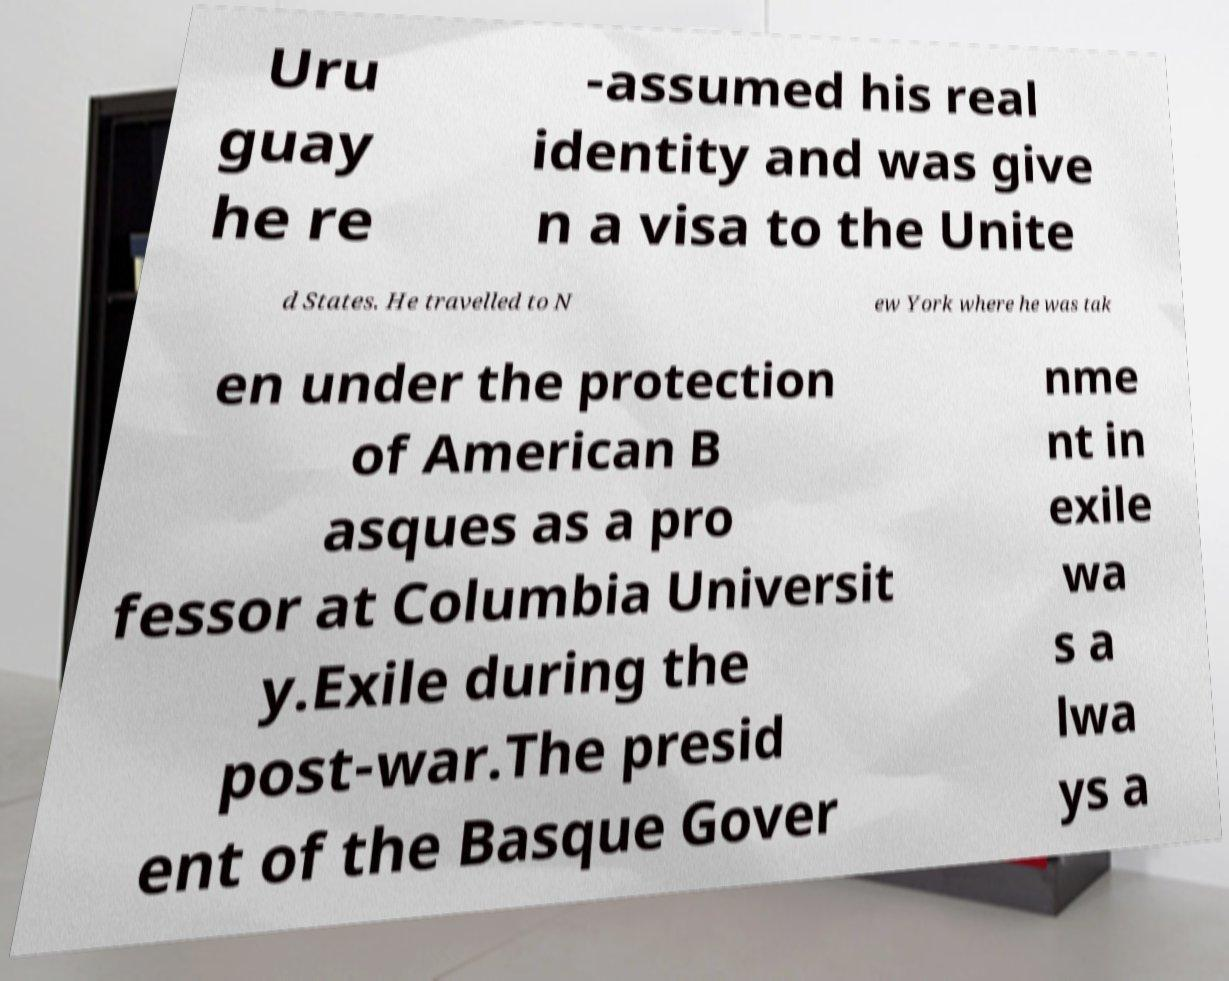Can you accurately transcribe the text from the provided image for me? Uru guay he re -assumed his real identity and was give n a visa to the Unite d States. He travelled to N ew York where he was tak en under the protection of American B asques as a pro fessor at Columbia Universit y.Exile during the post-war.The presid ent of the Basque Gover nme nt in exile wa s a lwa ys a 